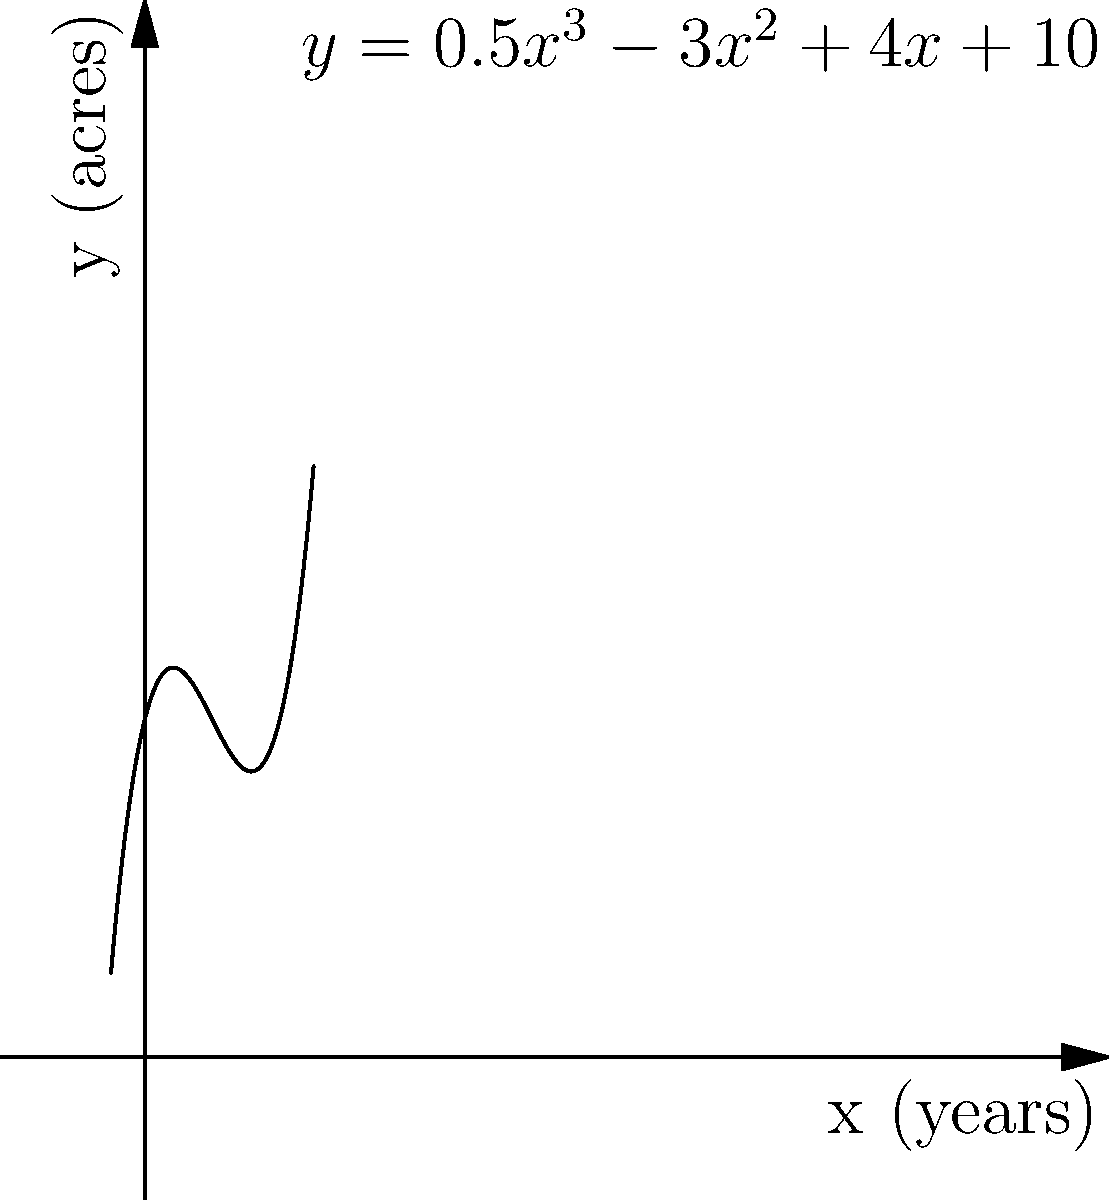The function $f(x) = 0.5x^3 - 3x^2 + 4x + 10$ represents the average farm size in acres ($y$) over time in years ($x$) for a particular region. At what point in time is the rate of change in farm size the smallest? To find the point where the rate of change is smallest, we need to follow these steps:

1) The rate of change is represented by the first derivative of the function. Let's calculate $f'(x)$:
   $f'(x) = 1.5x^2 - 6x + 4$

2) The point where the rate of change is smallest is where the second derivative equals zero. Let's calculate $f''(x)$:
   $f''(x) = 3x - 6$

3) Set $f''(x) = 0$ and solve for $x$:
   $3x - 6 = 0$
   $3x = 6$
   $x = 2$

4) To confirm this is a minimum (smallest rate of change) and not a maximum, we can check the sign of $f'''(x)$:
   $f'''(x) = 3$, which is positive, confirming a minimum.

5) Therefore, the rate of change is smallest when $x = 2$, or after 2 years.
Answer: 2 years 